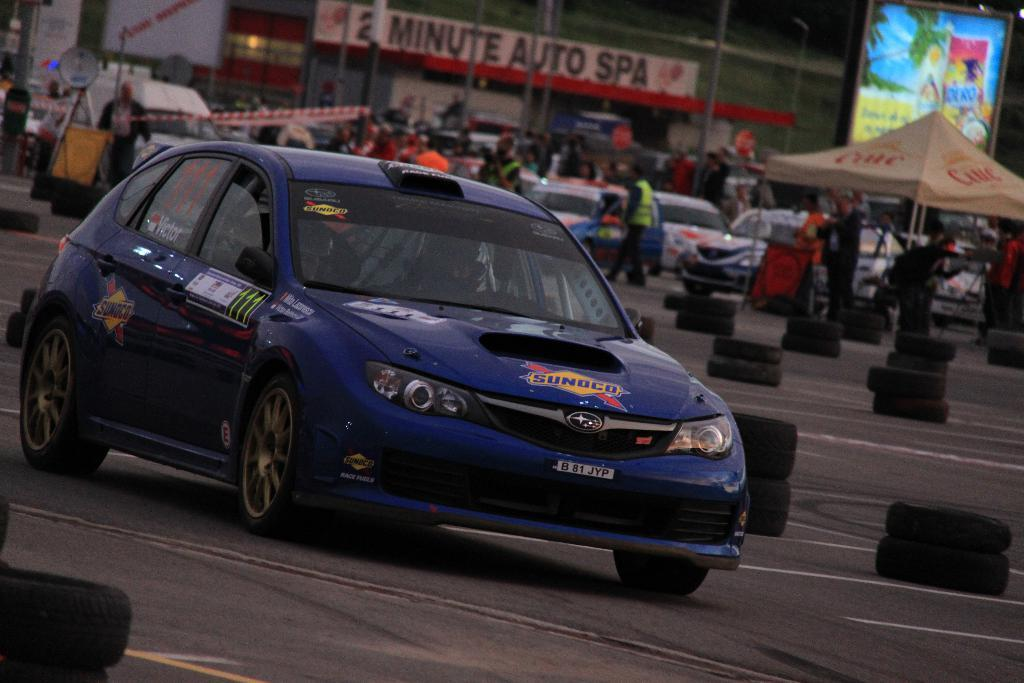What can be seen on the road in the image? There are vehicles on the road in the image. What are the people behind the vehicles doing? The people standing behind the vehicles are likely observing or waiting for something. What type of temporary shelter is present in the image? There are tents in the image. What type of structures can be seen in the image? There are buildings in the image. What type of barrier is present in the image? There is fencing in the image. What type of maid is visible in the image? There is no maid present in the image. How many cats can be seen playing with the vehicles in the image? There are no cats present in the image; only vehicles, people, tents, buildings, and fencing can be seen. 